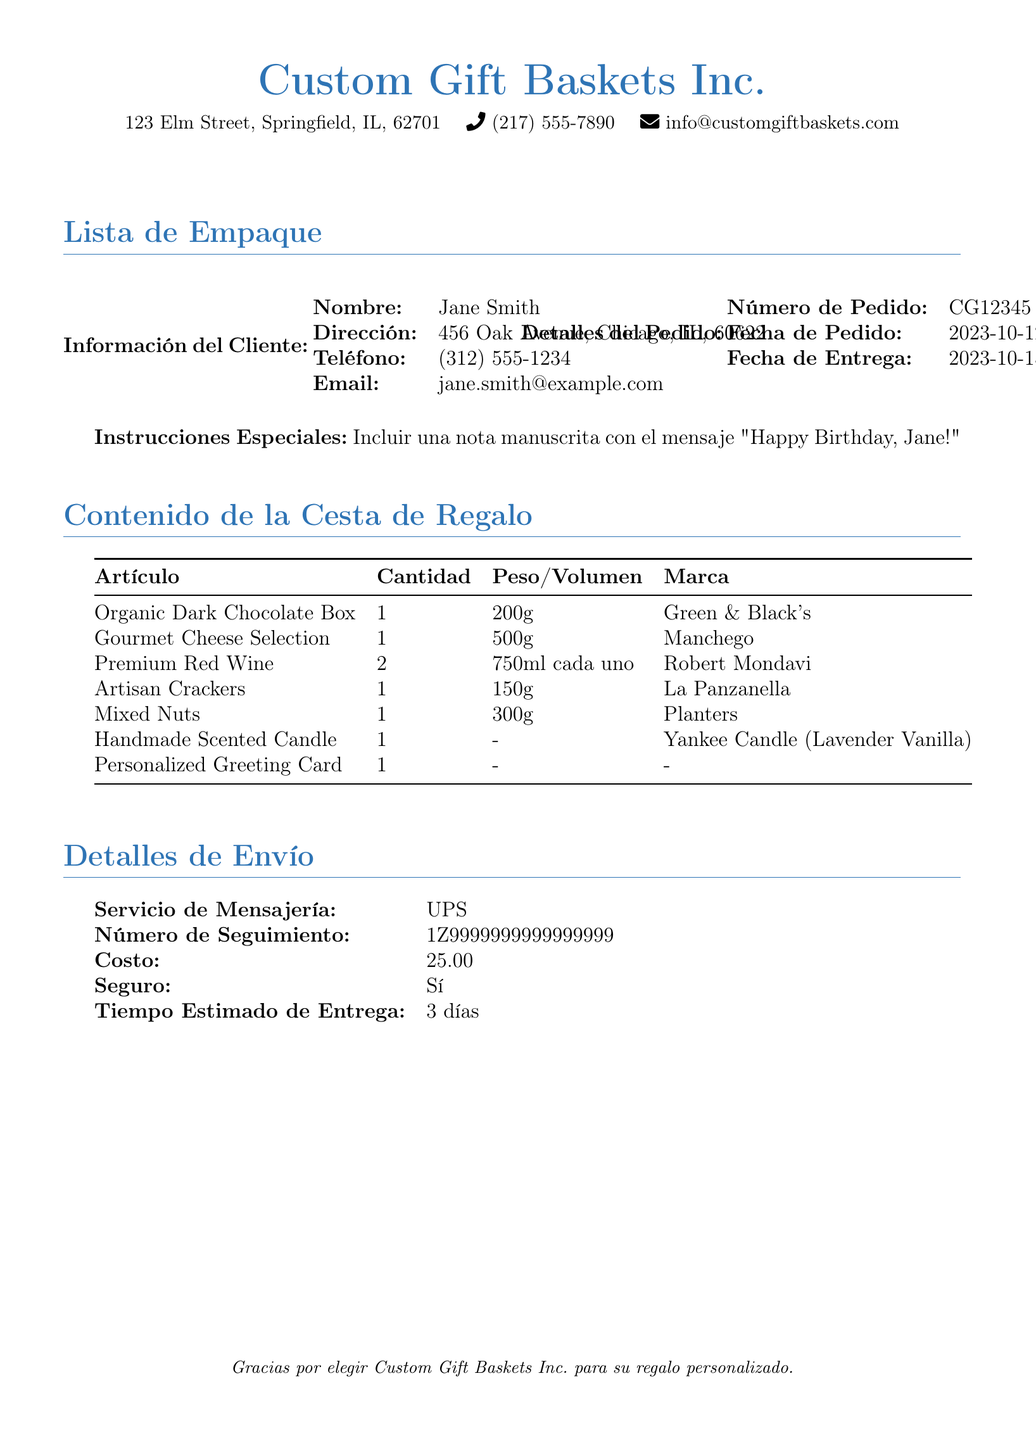¿Qué nombre aparece en la información del cliente? El nombre del cliente se encuentra en la sección de Información del Cliente bajo el título "Nombre".
Answer: Jane Smith ¿Cuál es la dirección de entrega? La dirección de entrega se encuentra en la sección de Información del Cliente bajo el título "Dirección".
Answer: 456 Oak Avenue, Chicago, IL, 60622 ¿Cuál es el número de pedido? El número de pedido está indicado en la sección de Detalles del Pedido bajo el título "Número de Pedido".
Answer: CG12345 ¿Cuántas botellas de vino se incluyen en la cesta de regalo? La cantidad de botellas de vino está en la sección de Contenido de la Cesta de Regalo, bajo el artículo "Premium Red Wine".
Answer: 2 ¿Qué mensaje especial se debe incluir? Las instrucciones especiales se mencionan en la sección titulada "Instrucciones Especiales".
Answer: Happy Birthday, Jane! ¿Cuál es el costo del envío? El costo del envío se encuentra en la sección de Detalles de Envío bajo el título "Costo".
Answer: 25.00 ¿Qué tipo de servicio de mensajería se utiliza? El servicio de mensajería está especificado en la sección de Detalles de Envío bajo el título "Servicio de Mensajería".
Answer: UPS ¿Cuál es la fecha de entrega estimada? La fecha de entrega estimada se muestra en la sección de Detalles del Pedido bajo el título "Fecha de Entrega".
Answer: 2023-10-15 ¿Cuál es el peso de la caja de chocolates orgánicos? Esta información se incluye en la sección de Contenido de la Cesta de Regalo, bajo el artículo "Organic Dark Chocolate Box".
Answer: 200g 